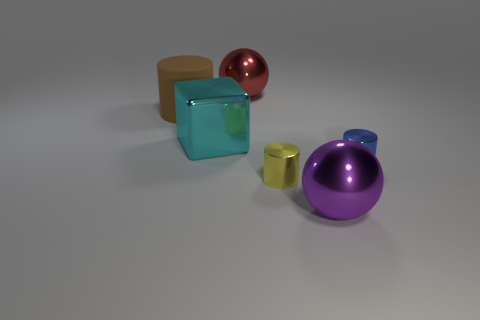Is there a yellow thing of the same size as the brown matte cylinder?
Ensure brevity in your answer.  No. There is a metal ball that is in front of the big metal sphere that is behind the large matte object; what is its size?
Offer a very short reply. Large. What number of tiny things have the same color as the big matte object?
Keep it short and to the point. 0. The large shiny object on the left side of the large shiny sphere that is behind the large rubber cylinder is what shape?
Your answer should be very brief. Cube. How many blue objects have the same material as the small blue cylinder?
Your answer should be compact. 0. There is a tiny object that is to the left of the small blue cylinder; what is it made of?
Ensure brevity in your answer.  Metal. The large thing right of the large metal sphere on the left side of the tiny metallic cylinder that is left of the tiny blue shiny object is what shape?
Your response must be concise. Sphere. Are there fewer small yellow shiny objects that are in front of the large rubber object than tiny objects to the right of the purple object?
Your answer should be very brief. No. Is there anything else that has the same shape as the cyan metallic thing?
Provide a succinct answer. No. What color is the other small metallic object that is the same shape as the yellow thing?
Give a very brief answer. Blue. 